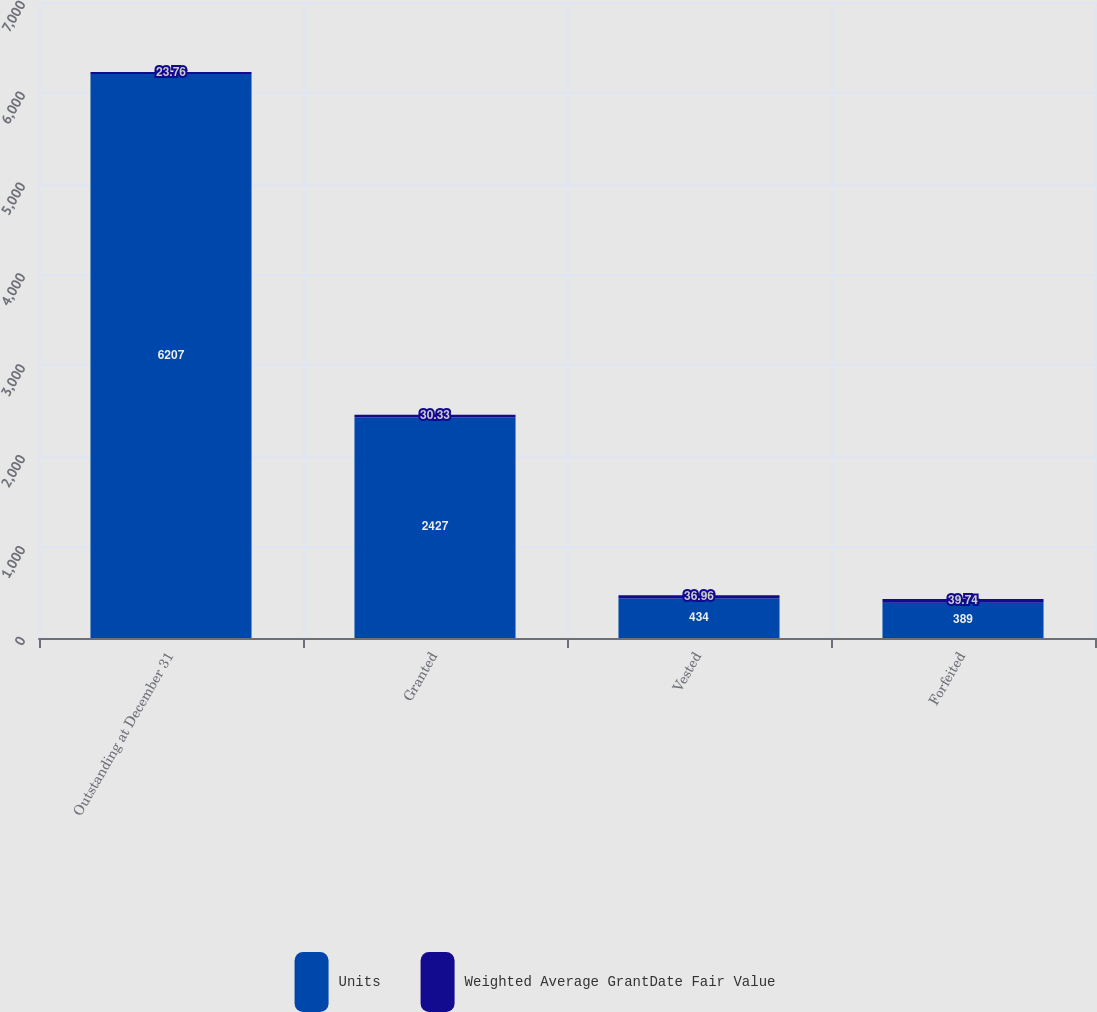<chart> <loc_0><loc_0><loc_500><loc_500><stacked_bar_chart><ecel><fcel>Outstanding at December 31<fcel>Granted<fcel>Vested<fcel>Forfeited<nl><fcel>Units<fcel>6207<fcel>2427<fcel>434<fcel>389<nl><fcel>Weighted Average GrantDate Fair Value<fcel>23.76<fcel>30.33<fcel>36.96<fcel>39.74<nl></chart> 